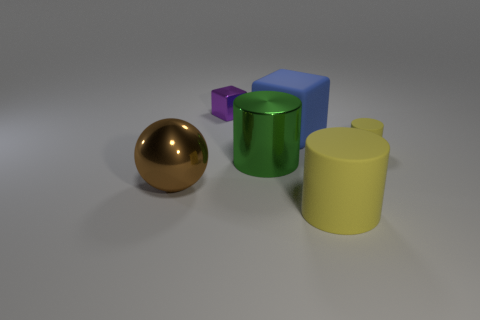Subtract all metallic cylinders. How many cylinders are left? 2 Add 2 large yellow matte objects. How many objects exist? 8 Subtract all cyan cylinders. Subtract all yellow balls. How many cylinders are left? 3 Subtract all balls. How many objects are left? 5 Add 1 big yellow rubber things. How many big yellow rubber things exist? 2 Subtract 0 blue cylinders. How many objects are left? 6 Subtract all big green metallic cubes. Subtract all yellow rubber cylinders. How many objects are left? 4 Add 6 large green objects. How many large green objects are left? 7 